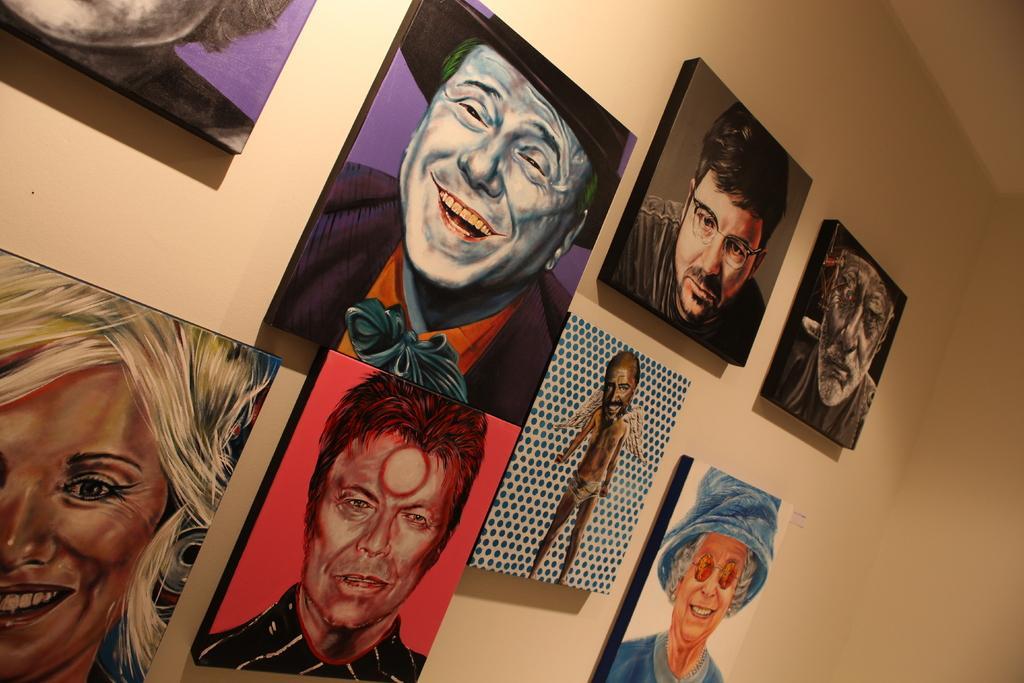In one or two sentences, can you explain what this image depicts? In this image we can see wall hangings attached to the wall. 